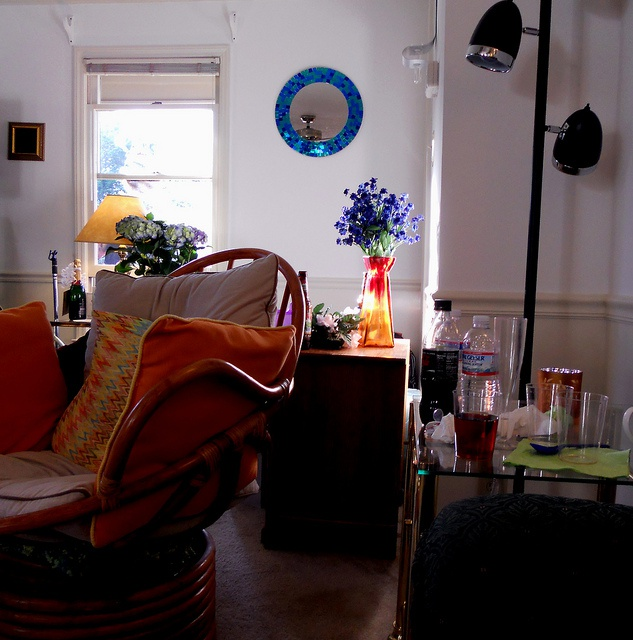Describe the objects in this image and their specific colors. I can see chair in gray, black, maroon, and brown tones, bottle in gray, black, and white tones, cup in gray, maroon, and black tones, vase in gray, white, orange, and red tones, and cup in gray, black, and darkgreen tones in this image. 